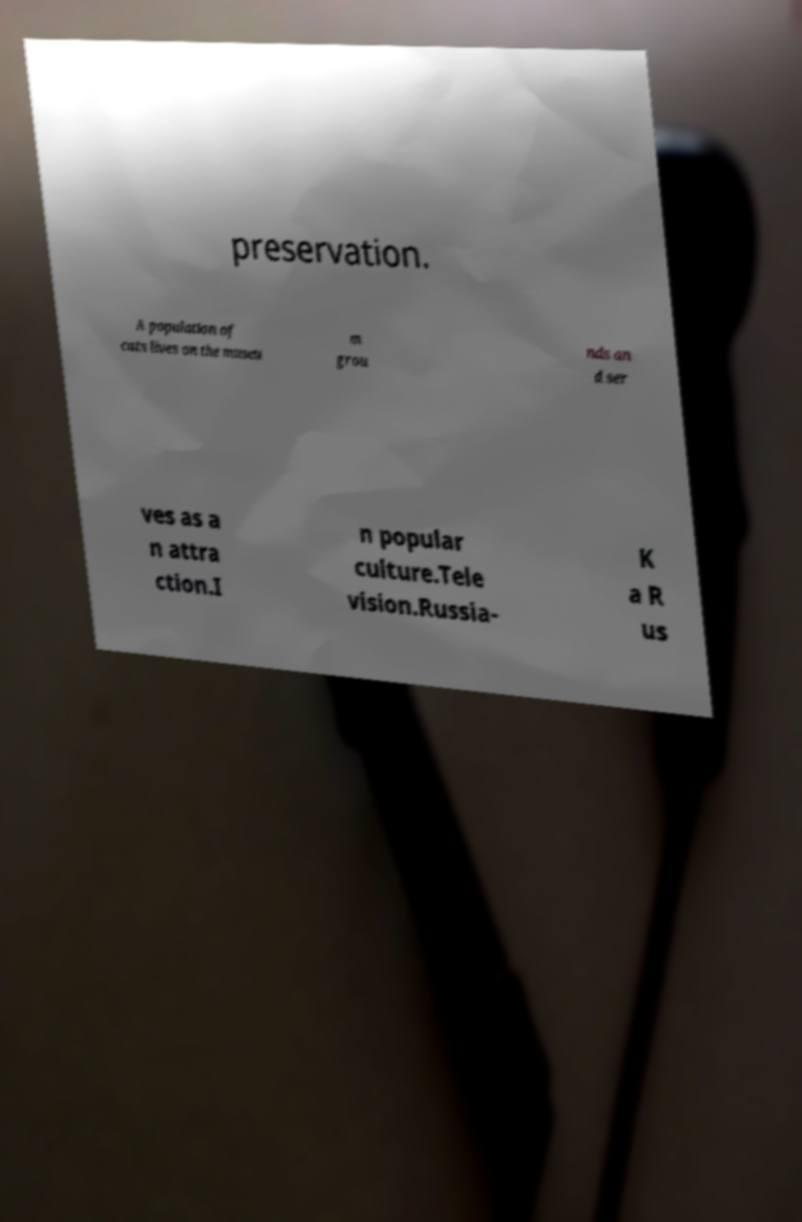Please identify and transcribe the text found in this image. preservation. A population of cats lives on the museu m grou nds an d ser ves as a n attra ction.I n popular culture.Tele vision.Russia- K a R us 